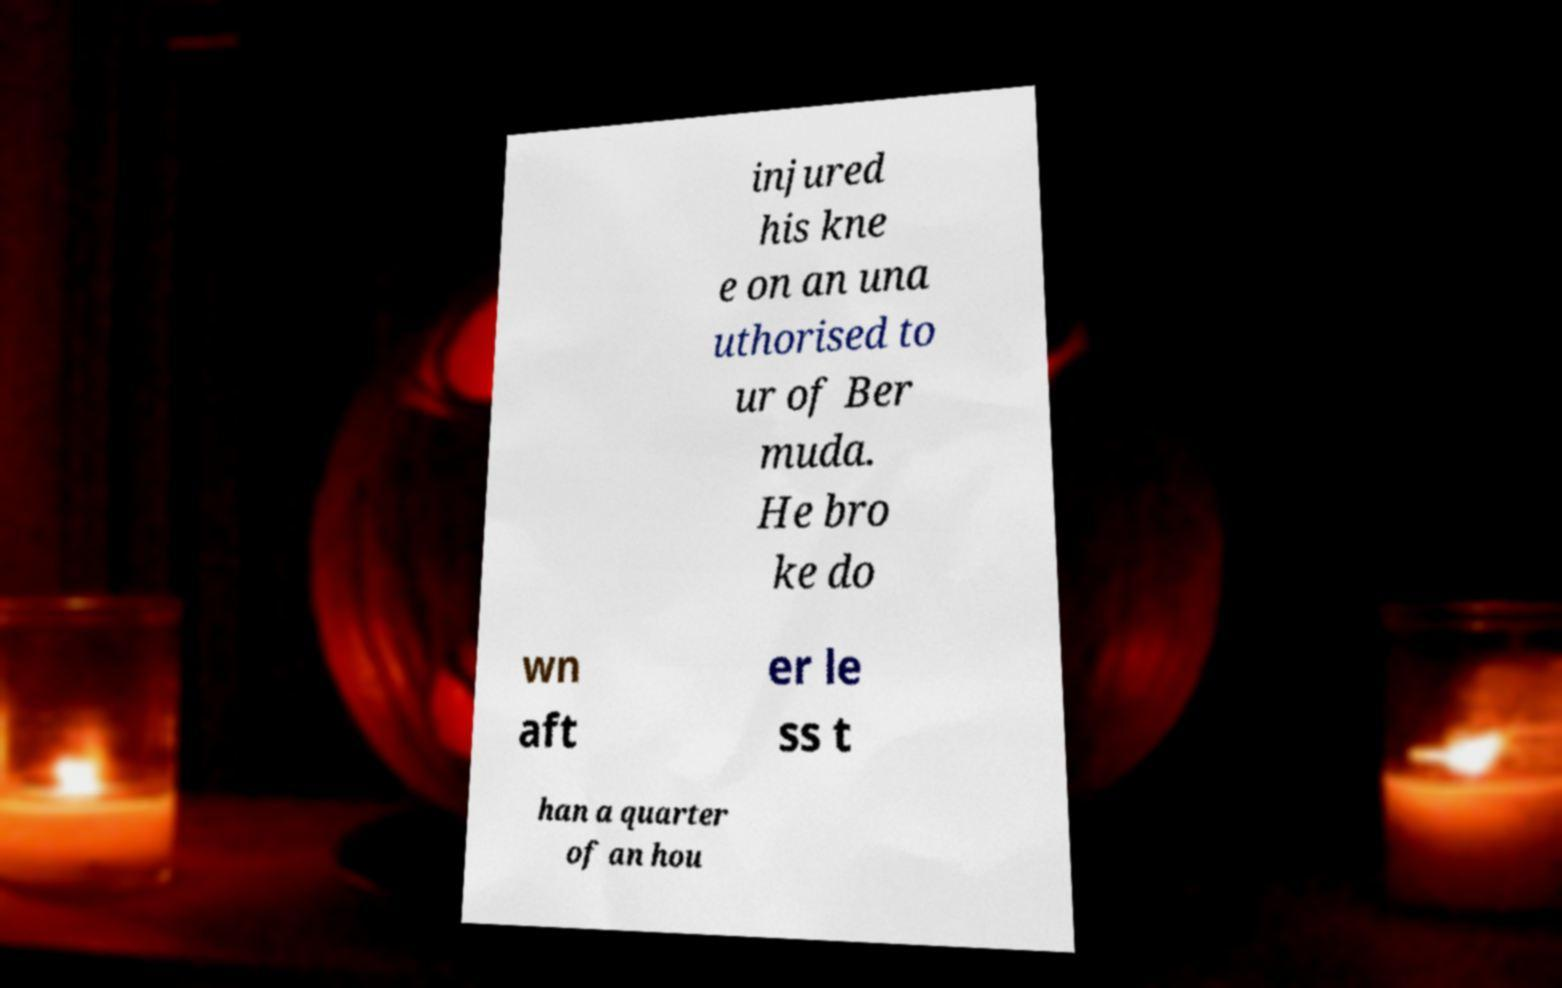Can you accurately transcribe the text from the provided image for me? injured his kne e on an una uthorised to ur of Ber muda. He bro ke do wn aft er le ss t han a quarter of an hou 